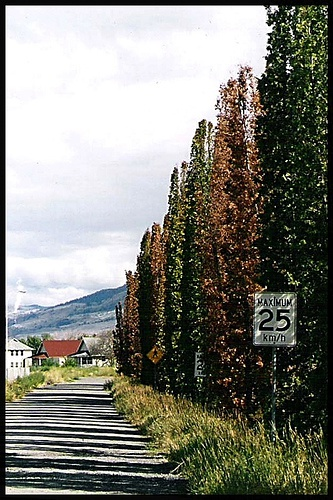Describe the objects in this image and their specific colors. I can see various objects in this image with different colors. 